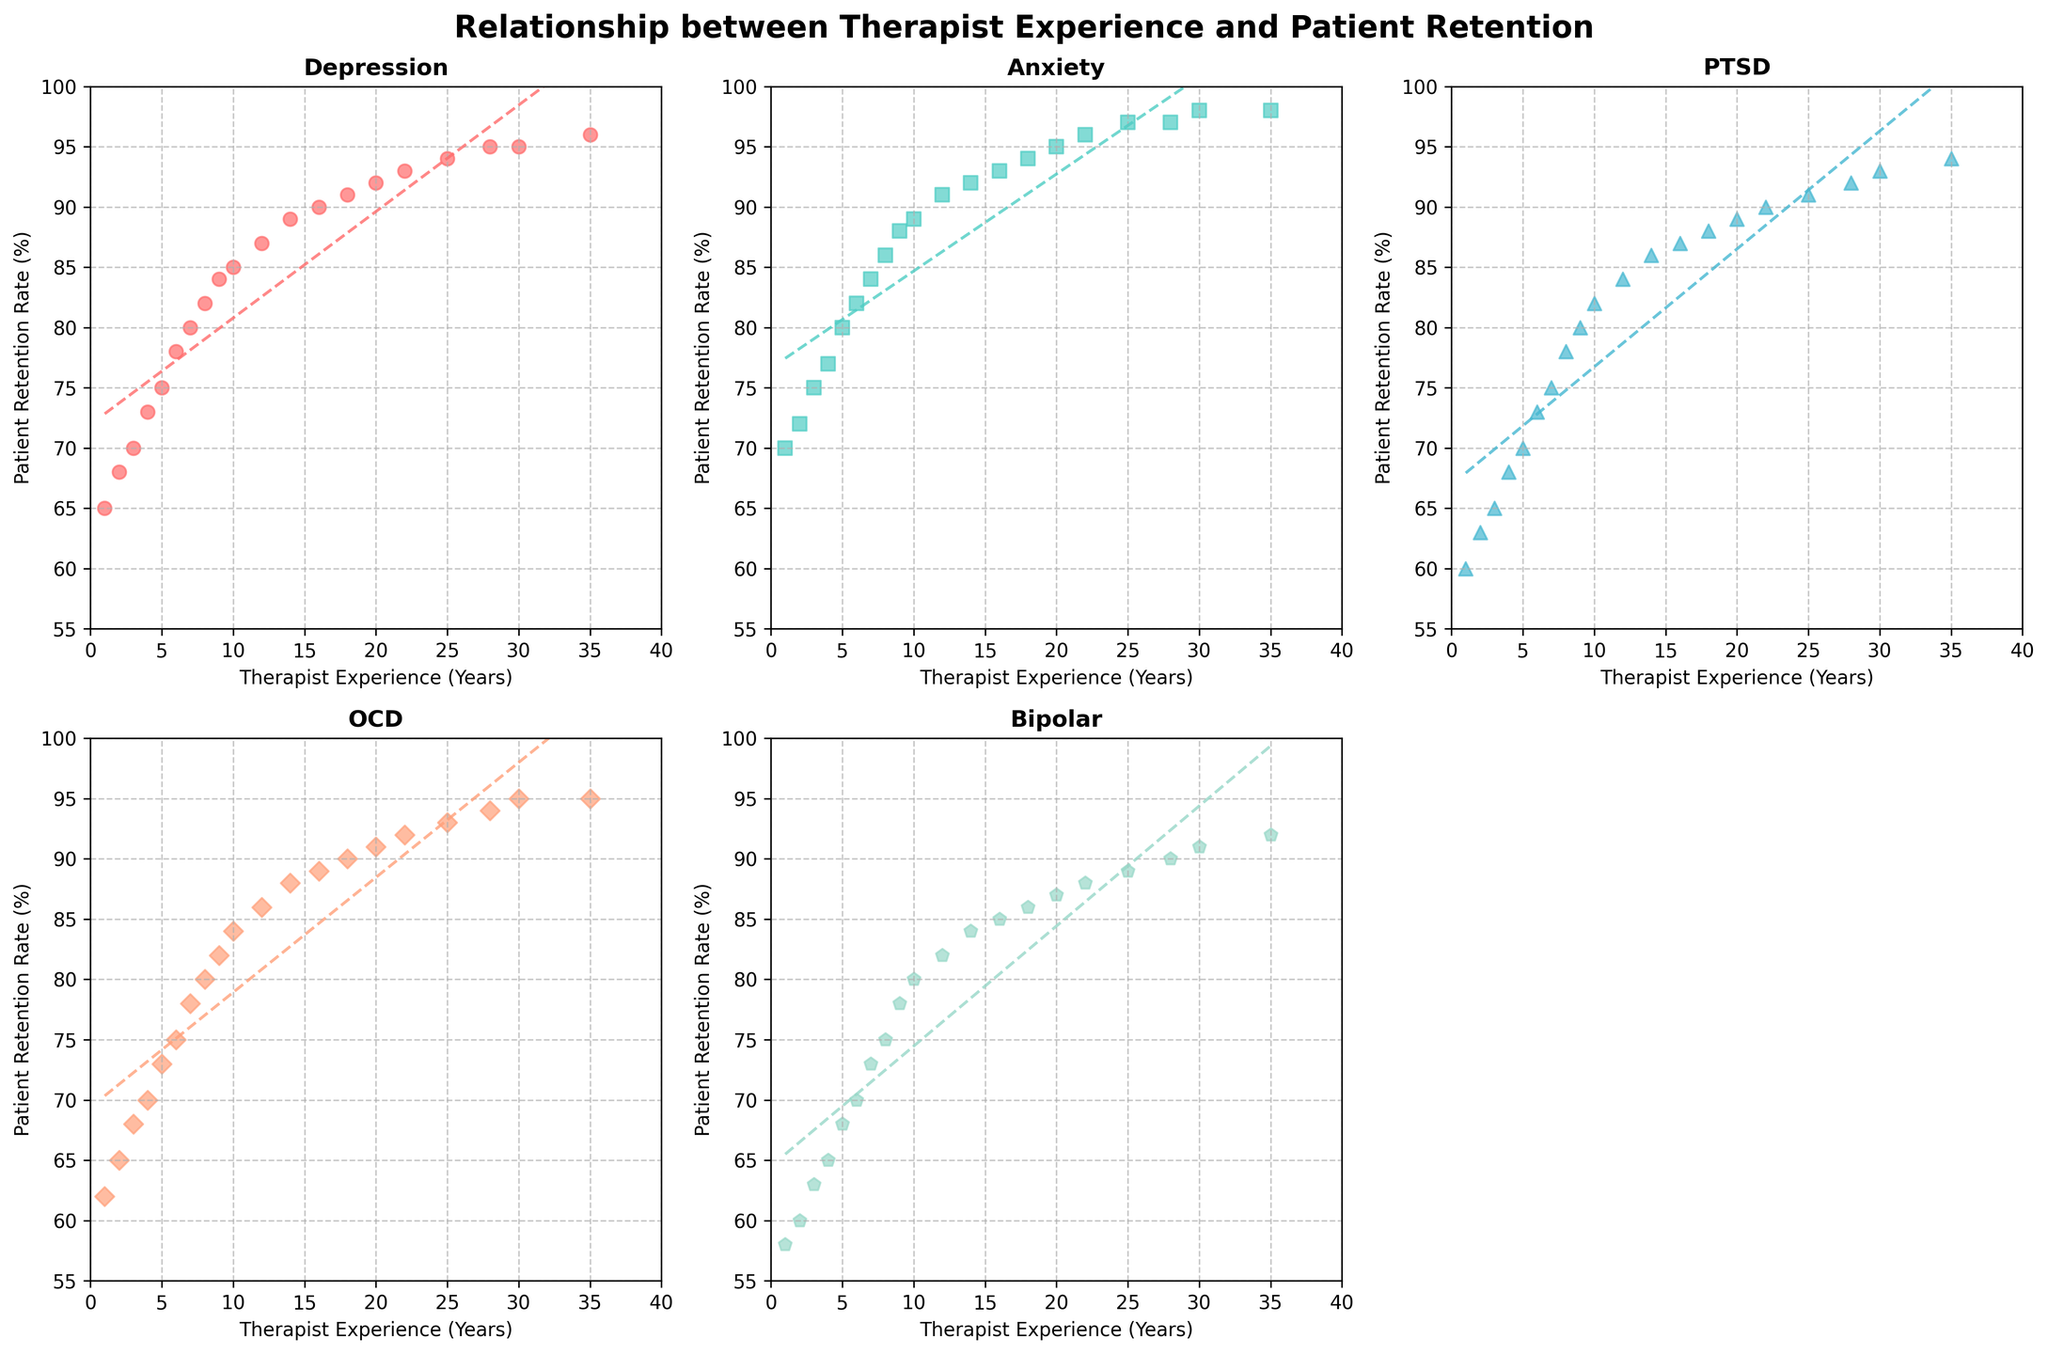What trend is observed between therapist experience and depression retention rates? As the years of therapist experience increase, the depression retention rates also increase. The scatter plot shows that retention rates rise from around 65% when therapists have 1 year of experience to about 96% when they have 35 years of experience.
Answer: Retention rates increase Which mental health issue shows the steepest increase in retention rate as therapist experience increases? By observing the trendlines, Anxiety shows the steepest increase in retention rate as therapist experience increases. The slope of the trendline in the Anxiety subplot is steeper compared to the trendlines in other subplots.
Answer: Anxiety Compare the retention rates for PTSD and OCD when therapists have 10 years of experience. Referring to their respective scatter plots, PTSD retention is at approximately 82% and OCD retention is around 84% when therapists have 10 years of experience.
Answer: PTSD: 82%, OCD: 84% Which mental health issue has the highest retention rate for therapists with 30 years of experience? By looking at the scatter plots, Anxiety has the highest retention rate for therapists with 30 years of experience, reaching around 98%.
Answer: Anxiety For which mental health issue does the retention rate reach 90% first as the therapist gains experience? The subplot for Anxiety shows that the retention rate reaches 90% around 14 years of experience.
Answer: Anxiety What is the difference in retention rates for Bipolar disorder between 5 and 16 years of therapist experience? Referring to the scatter plot for Bipolar disorder, the retention rate at 5 years is approximately 68%, and at 16 years, it is around 85%. The difference is 85% - 68% = 17%.
Answer: 17% How does the retention rate for Depression at 25 years of experience compare to the retention rate for Anxiety at the same experience level? At 25 years of experience, the retention rate for Depression is about 94%, while for Anxiety, it is approximately 97%.
Answer: Depression: 94%, Anxiety: 97% What is the approximate retention rate for OCD at 9 years of experience? By observing the scatter plot for OCD, the retention rate at 9 years of experience is around 82%.
Answer: 82% Which mental health issue shows the least variation in retention rates as therapist experience increases? By observing the scatter plots, Bipolar disorder shows the least variation in retention rates. The points are closer together, indicating less variation compared to the other issues.
Answer: Bipolar disorder 